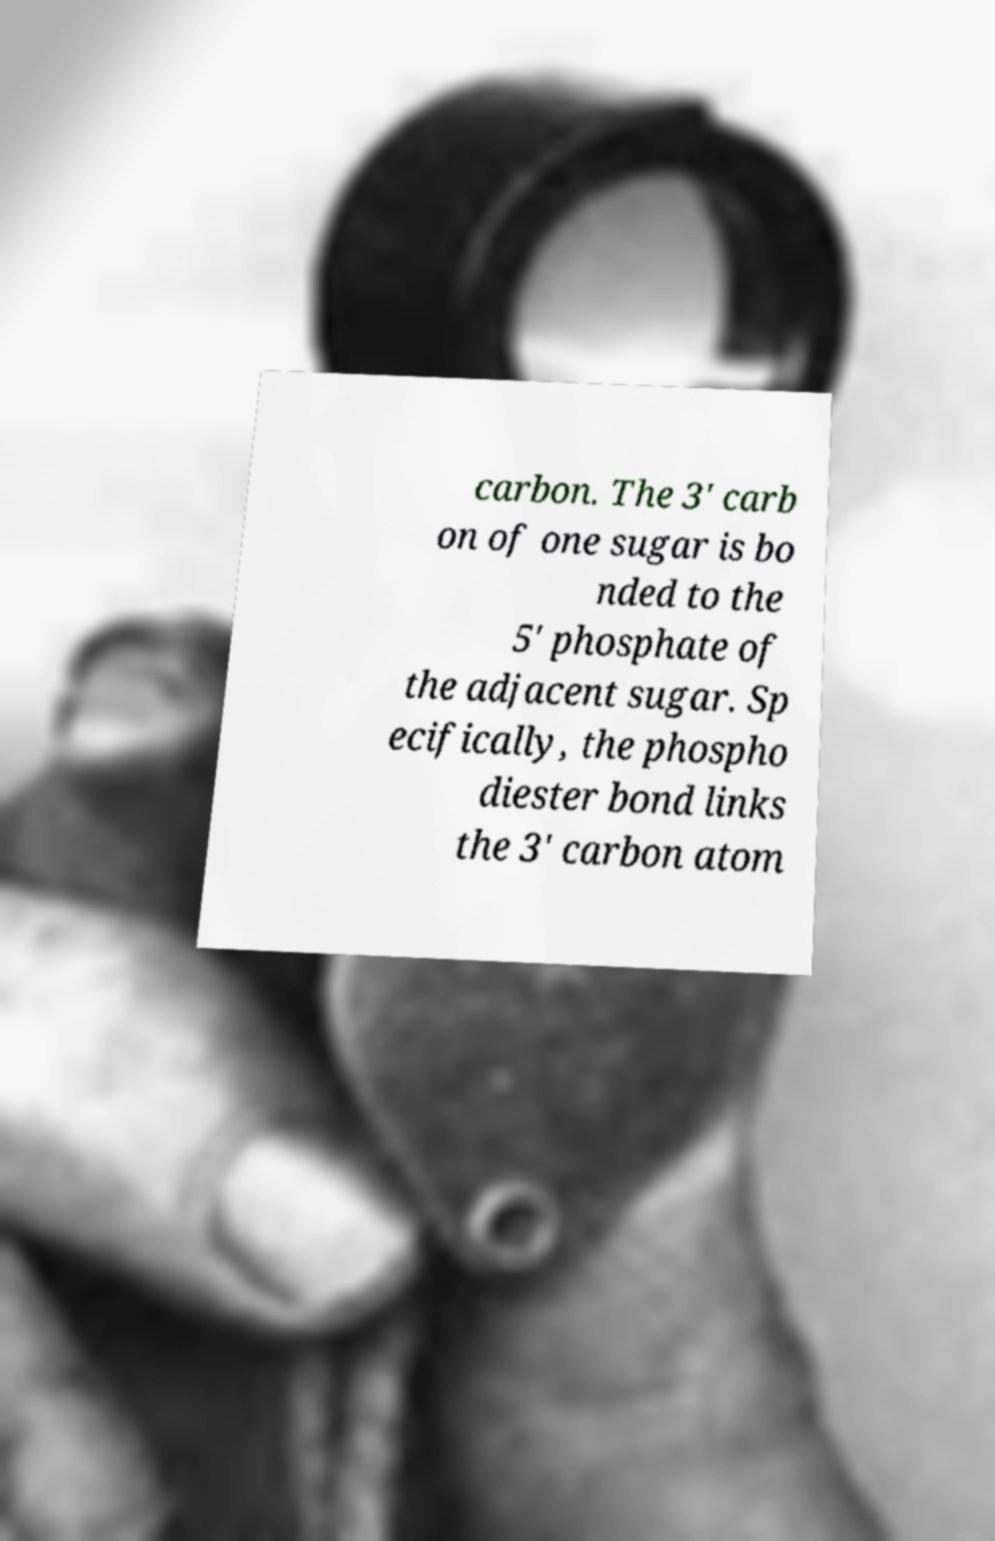Could you extract and type out the text from this image? carbon. The 3' carb on of one sugar is bo nded to the 5' phosphate of the adjacent sugar. Sp ecifically, the phospho diester bond links the 3' carbon atom 